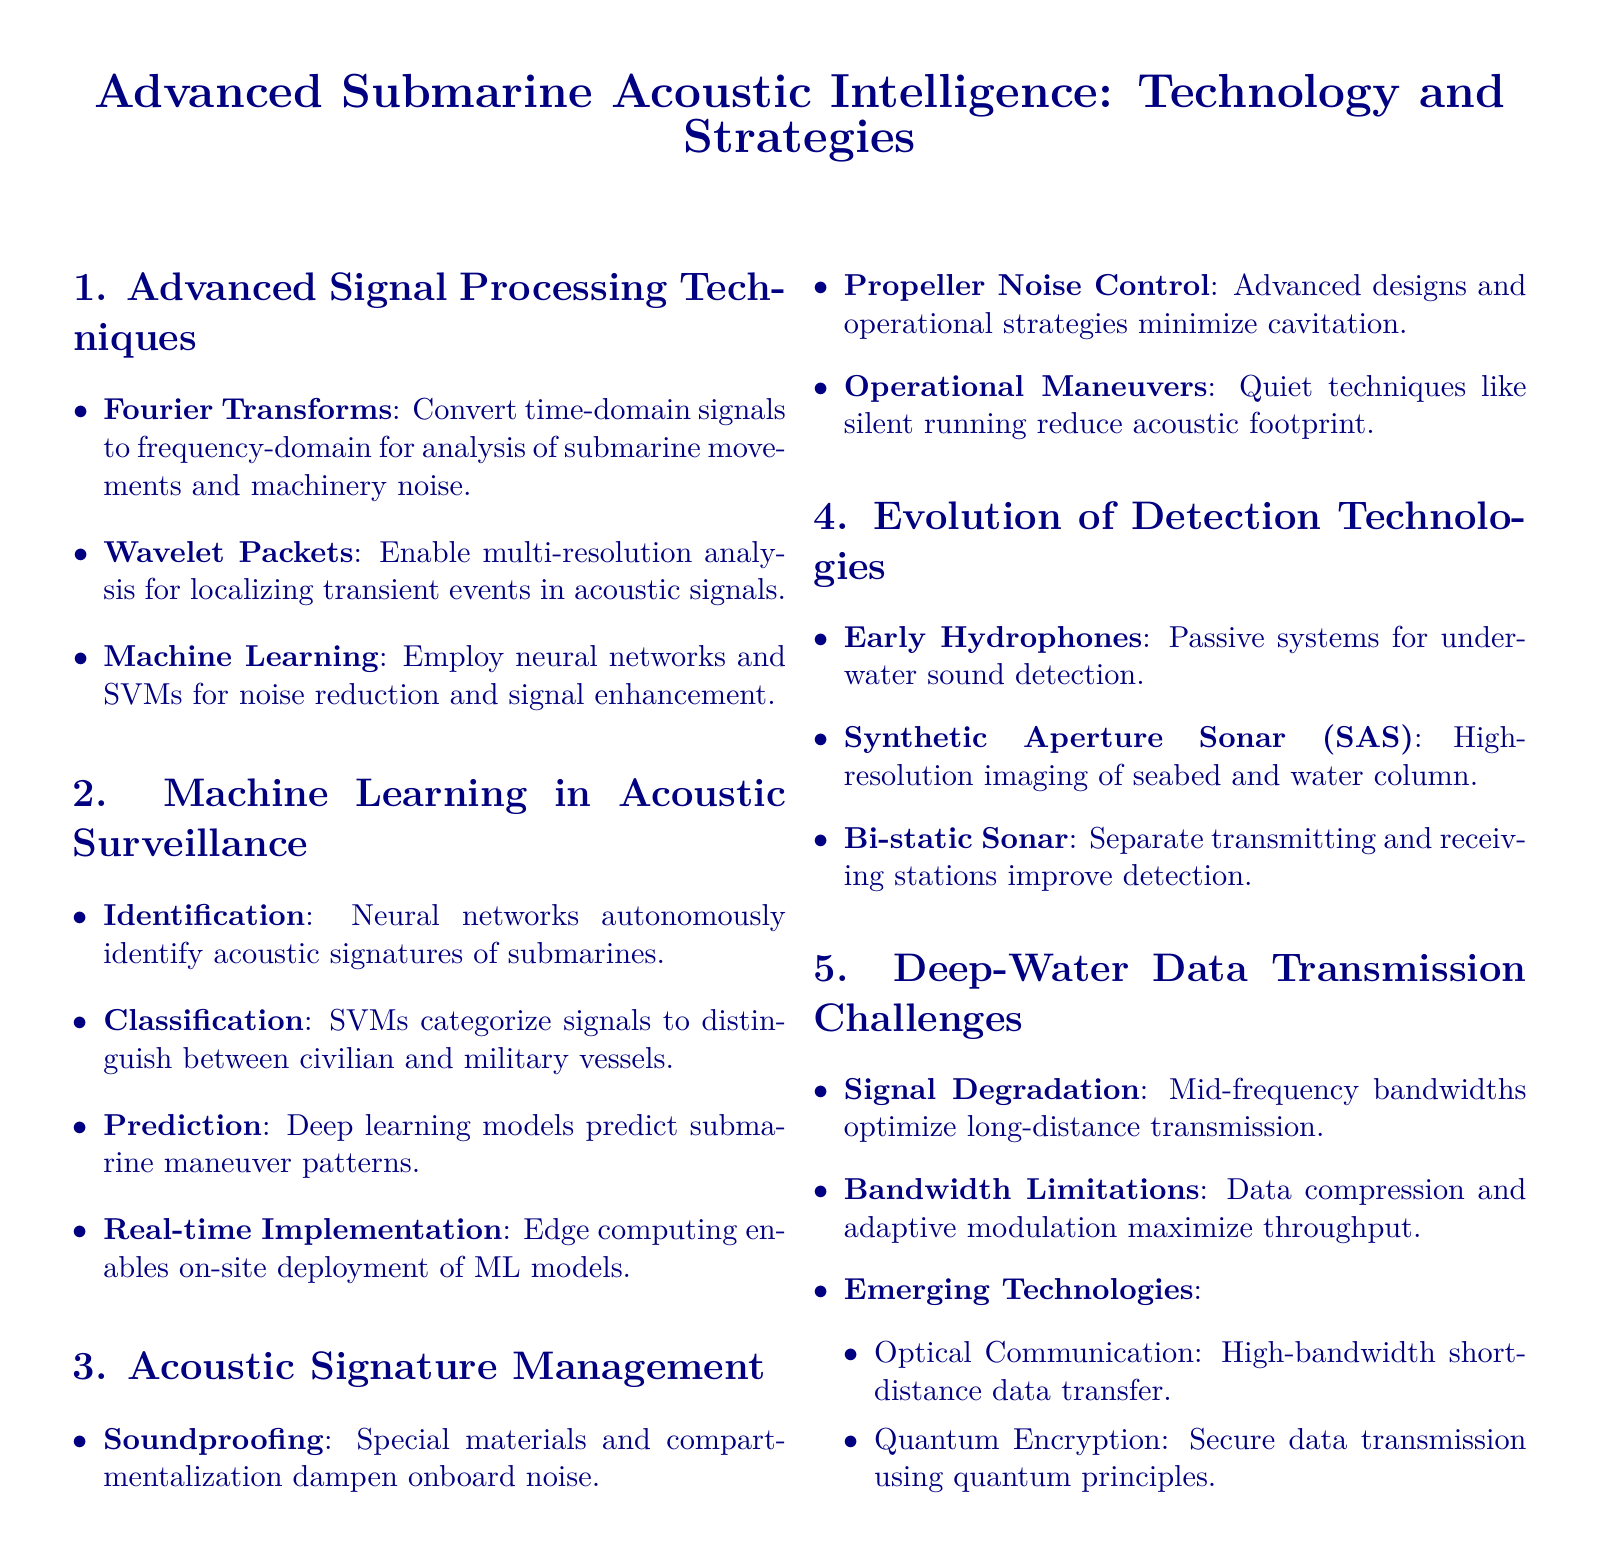What is one technique used for noise reduction in submarines? Noise reduction techniques are highlighted, including machine learning methods such as neural networks.
Answer: machine learning What is the benefit of using Wavelet Packets? Wavelet Packets enable multi-resolution analysis which aids in localizing transient events in acoustic signals.
Answer: localizing transient events What type of sonar provides high-resolution imaging? The document lists Synthetic Aperture Sonar (SAS) as a key technology for high-resolution imaging.
Answer: Synthetic Aperture Sonar What are two emerging technologies mentioned for data transmission? The document describes optical communication and quantum encryption as emerging technologies in underwater communication links.
Answer: optical communication, quantum encryption What is one strategy for minimizing propeller noise? Advanced designs and operational strategies are discussed to control propeller noise reduction.
Answer: advanced designs 